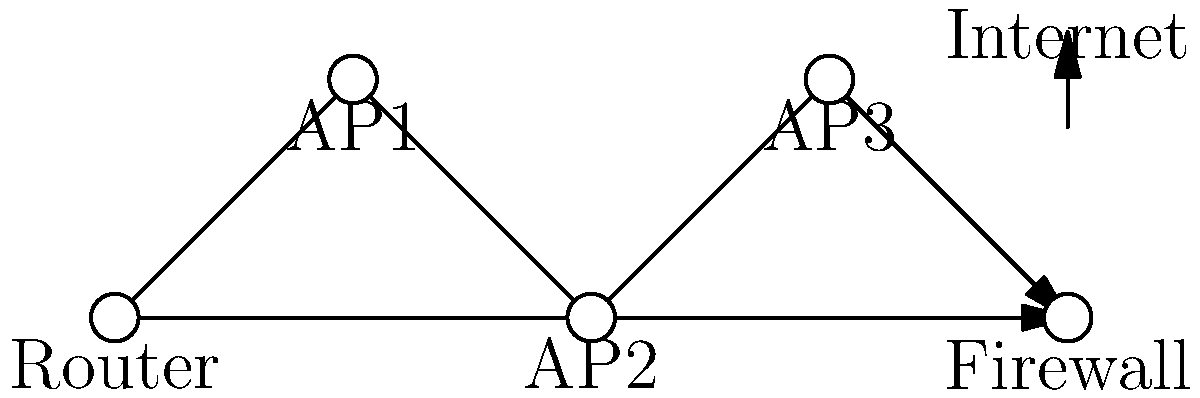Given the network topology diagram for a convention center's wireless infrastructure, what security measure should be implemented between the router and the wireless access points (APs) to enhance the overall network security? To enhance the security of the wireless network infrastructure for a convention center, we need to consider the following steps:

1. Analyze the network topology:
   - The diagram shows a router connected to multiple wireless access points (APs) and a firewall.
   - The firewall is positioned between the router and the internet, providing perimeter security.

2. Identify potential vulnerabilities:
   - The connection between the router and APs is a potential weak point.
   - Unauthorized devices could potentially connect to the APs or intercept traffic between the router and APs.

3. Consider security best practices for wireless networks:
   - Encryption of wireless traffic is crucial to prevent eavesdropping.
   - Segmentation of the network can limit the impact of a security breach.

4. Evaluate security measures:
   - A Virtual Local Area Network (VLAN) can be used to segment traffic between the router and APs.
   - VLANs can be combined with encryption protocols like IEEE 802.1Q for added security.

5. Implement the security measure:
   - Configure VLANs on the router and APs to create separate virtual networks for different types of traffic or user groups.
   - Implement IEEE 802.1Q tagging to ensure proper VLAN segregation and encryption of traffic between the router and APs.

By implementing VLANs with IEEE 802.1Q, we create a secure, segmented network that enhances the overall security of the convention center's wireless infrastructure. This measure provides traffic isolation, reduces the attack surface, and protects against unauthorized access and eavesdropping between the router and APs.
Answer: Implement VLANs with IEEE 802.1Q 